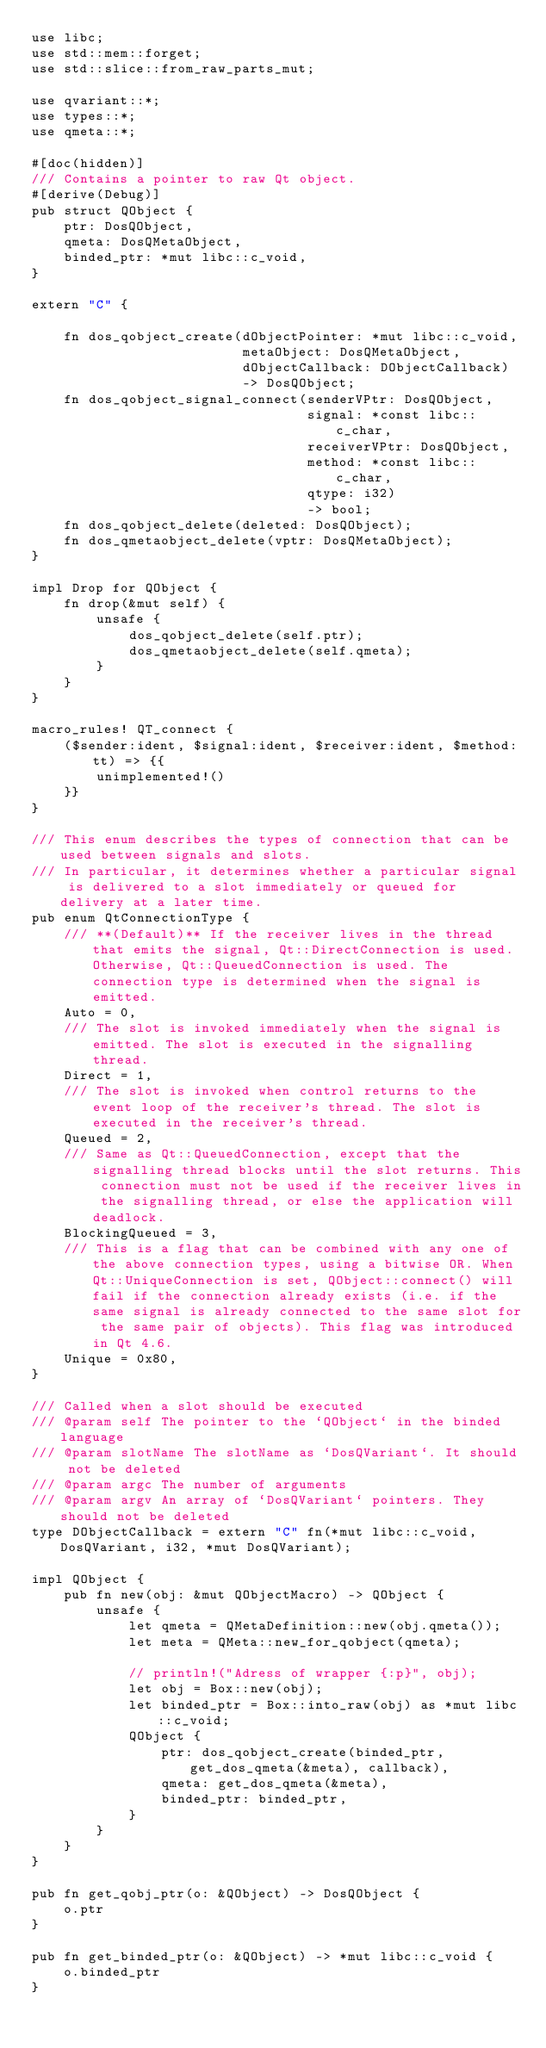Convert code to text. <code><loc_0><loc_0><loc_500><loc_500><_Rust_>use libc;
use std::mem::forget;
use std::slice::from_raw_parts_mut;

use qvariant::*;
use types::*;
use qmeta::*;

#[doc(hidden)]
/// Contains a pointer to raw Qt object.
#[derive(Debug)]
pub struct QObject {
    ptr: DosQObject,
    qmeta: DosQMetaObject,
    binded_ptr: *mut libc::c_void,
}

extern "C" {

    fn dos_qobject_create(dObjectPointer: *mut libc::c_void,
                          metaObject: DosQMetaObject,
                          dObjectCallback: DObjectCallback)
                          -> DosQObject;
    fn dos_qobject_signal_connect(senderVPtr: DosQObject,
                                  signal: *const libc::c_char,
                                  receiverVPtr: DosQObject,
                                  method: *const libc::c_char,
                                  qtype: i32)
                                  -> bool;
    fn dos_qobject_delete(deleted: DosQObject);
    fn dos_qmetaobject_delete(vptr: DosQMetaObject);
}

impl Drop for QObject {
    fn drop(&mut self) {
        unsafe {
            dos_qobject_delete(self.ptr);
            dos_qmetaobject_delete(self.qmeta);
        }
    }
}

macro_rules! QT_connect {
    ($sender:ident, $signal:ident, $receiver:ident, $method:tt) => {{
        unimplemented!()
    }}
}

/// This enum describes the types of connection that can be used between signals and slots.
/// In particular, it determines whether a particular signal is delivered to a slot immediately or queued for delivery at a later time.
pub enum QtConnectionType {
    /// **(Default)** If the receiver lives in the thread that emits the signal, Qt::DirectConnection is used. Otherwise, Qt::QueuedConnection is used. The connection type is determined when the signal is emitted.
    Auto = 0,
    /// The slot is invoked immediately when the signal is emitted. The slot is executed in the signalling thread.
    Direct = 1,
    /// The slot is invoked when control returns to the event loop of the receiver's thread. The slot is executed in the receiver's thread.
    Queued = 2,
    /// Same as Qt::QueuedConnection, except that the signalling thread blocks until the slot returns. This connection must not be used if the receiver lives in the signalling thread, or else the application will deadlock.
    BlockingQueued = 3,
    /// This is a flag that can be combined with any one of the above connection types, using a bitwise OR. When Qt::UniqueConnection is set, QObject::connect() will fail if the connection already exists (i.e. if the same signal is already connected to the same slot for the same pair of objects). This flag was introduced in Qt 4.6.
    Unique = 0x80,
}

/// Called when a slot should be executed
/// @param self The pointer to the `QObject` in the binded language
/// @param slotName The slotName as `DosQVariant`. It should not be deleted
/// @param argc The number of arguments
/// @param argv An array of `DosQVariant` pointers. They should not be deleted
type DObjectCallback = extern "C" fn(*mut libc::c_void, DosQVariant, i32, *mut DosQVariant);

impl QObject {
    pub fn new(obj: &mut QObjectMacro) -> QObject {
        unsafe {
            let qmeta = QMetaDefinition::new(obj.qmeta());
            let meta = QMeta::new_for_qobject(qmeta);

            // println!("Adress of wrapper {:p}", obj);
            let obj = Box::new(obj);
            let binded_ptr = Box::into_raw(obj) as *mut libc::c_void;
            QObject {
                ptr: dos_qobject_create(binded_ptr, get_dos_qmeta(&meta), callback),
                qmeta: get_dos_qmeta(&meta),
                binded_ptr: binded_ptr,
            }
        }
    }
}

pub fn get_qobj_ptr(o: &QObject) -> DosQObject {
    o.ptr
}

pub fn get_binded_ptr(o: &QObject) -> *mut libc::c_void {
    o.binded_ptr
}
</code> 